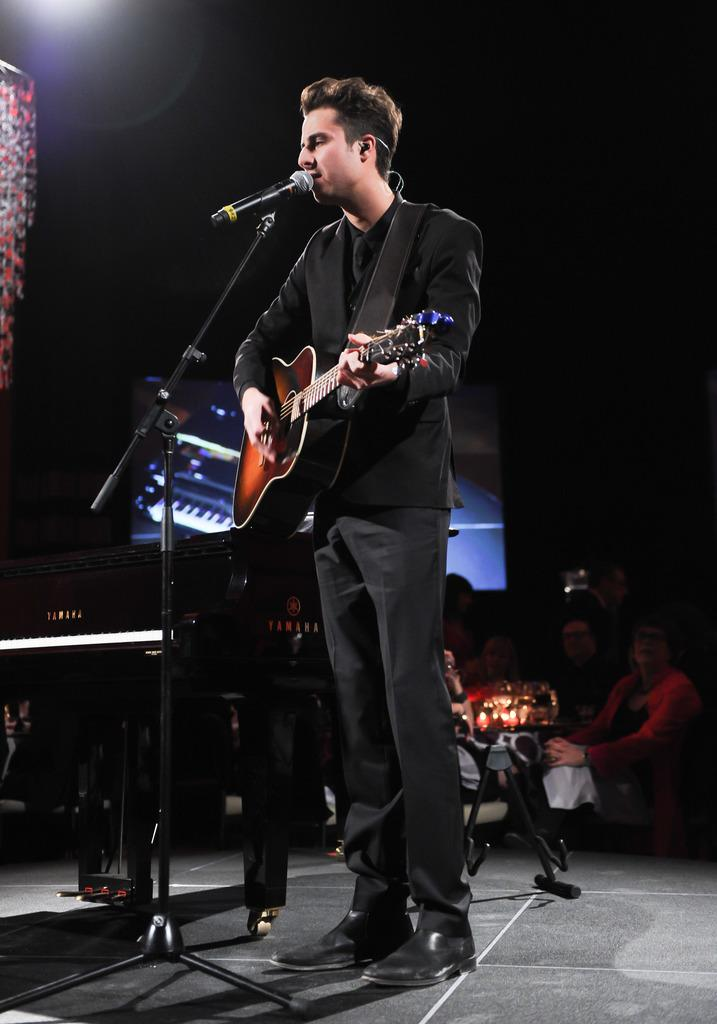What is the man in the image wearing? The man is wearing a black suit. What is the man doing in the image? The man is playing a guitar. What is in front of the man? There is a microphone in front of the man. What is the microphone attached to? The microphone is attached to a mic holder. Can you describe the people in the image? There are people sitting far from the man. What other musical instrument can be seen in the image? There is a piano keyboard in the image. What is on the wall in the image? There is a screen on the wall. What type of hope can be seen growing on the man's leg in the image? There is no mention of hope or a leg in the image; the man is wearing a black suit and playing a guitar. 